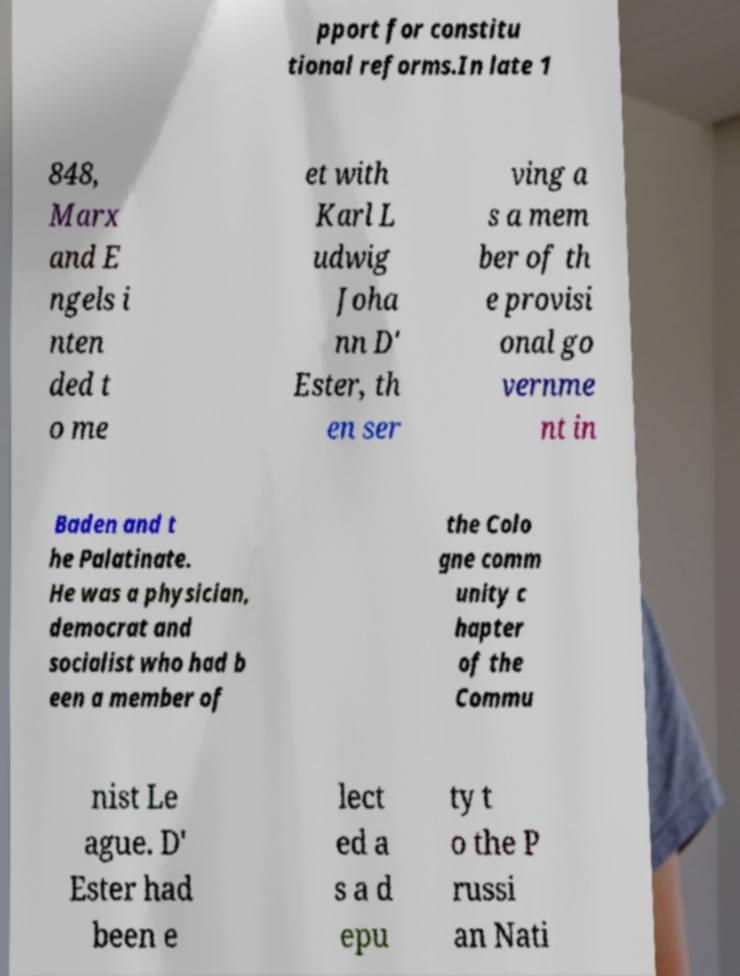Could you assist in decoding the text presented in this image and type it out clearly? pport for constitu tional reforms.In late 1 848, Marx and E ngels i nten ded t o me et with Karl L udwig Joha nn D' Ester, th en ser ving a s a mem ber of th e provisi onal go vernme nt in Baden and t he Palatinate. He was a physician, democrat and socialist who had b een a member of the Colo gne comm unity c hapter of the Commu nist Le ague. D' Ester had been e lect ed a s a d epu ty t o the P russi an Nati 